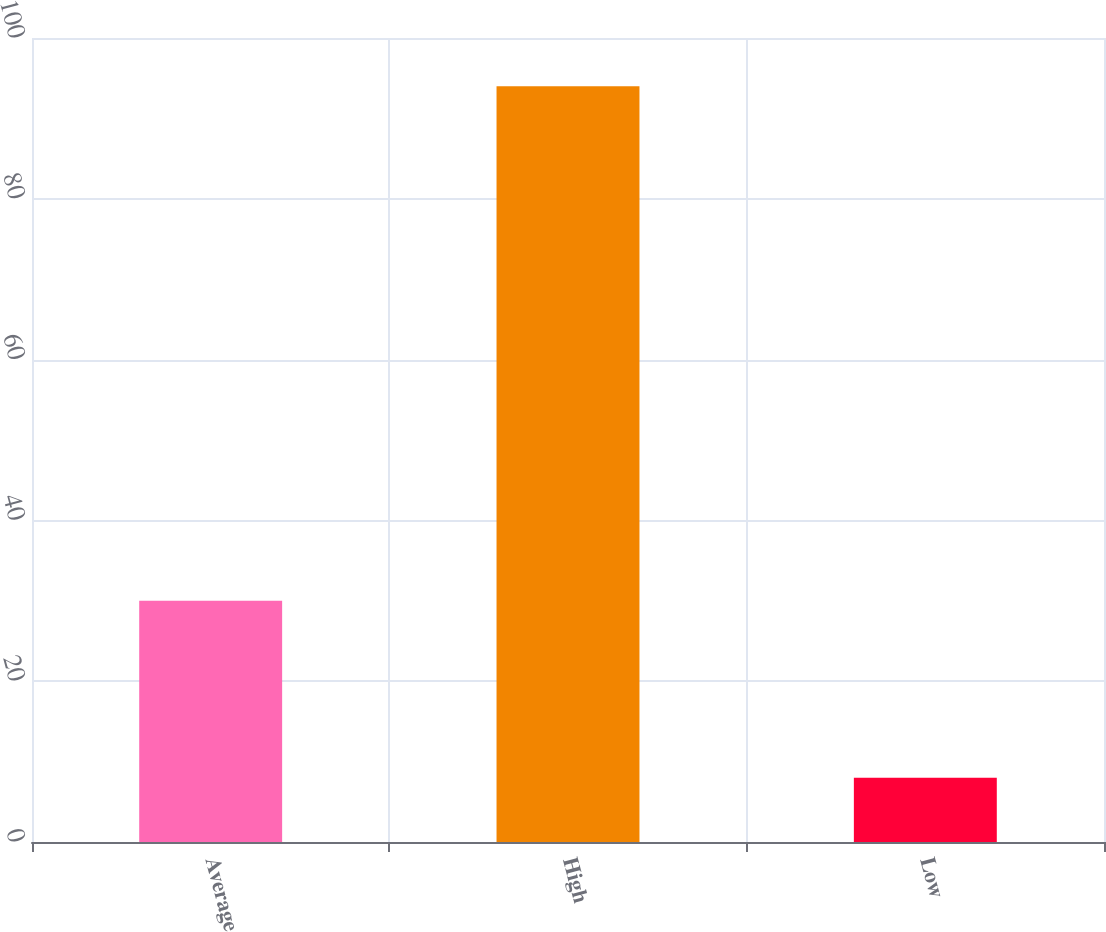Convert chart to OTSL. <chart><loc_0><loc_0><loc_500><loc_500><bar_chart><fcel>Average<fcel>High<fcel>Low<nl><fcel>30<fcel>94<fcel>8<nl></chart> 